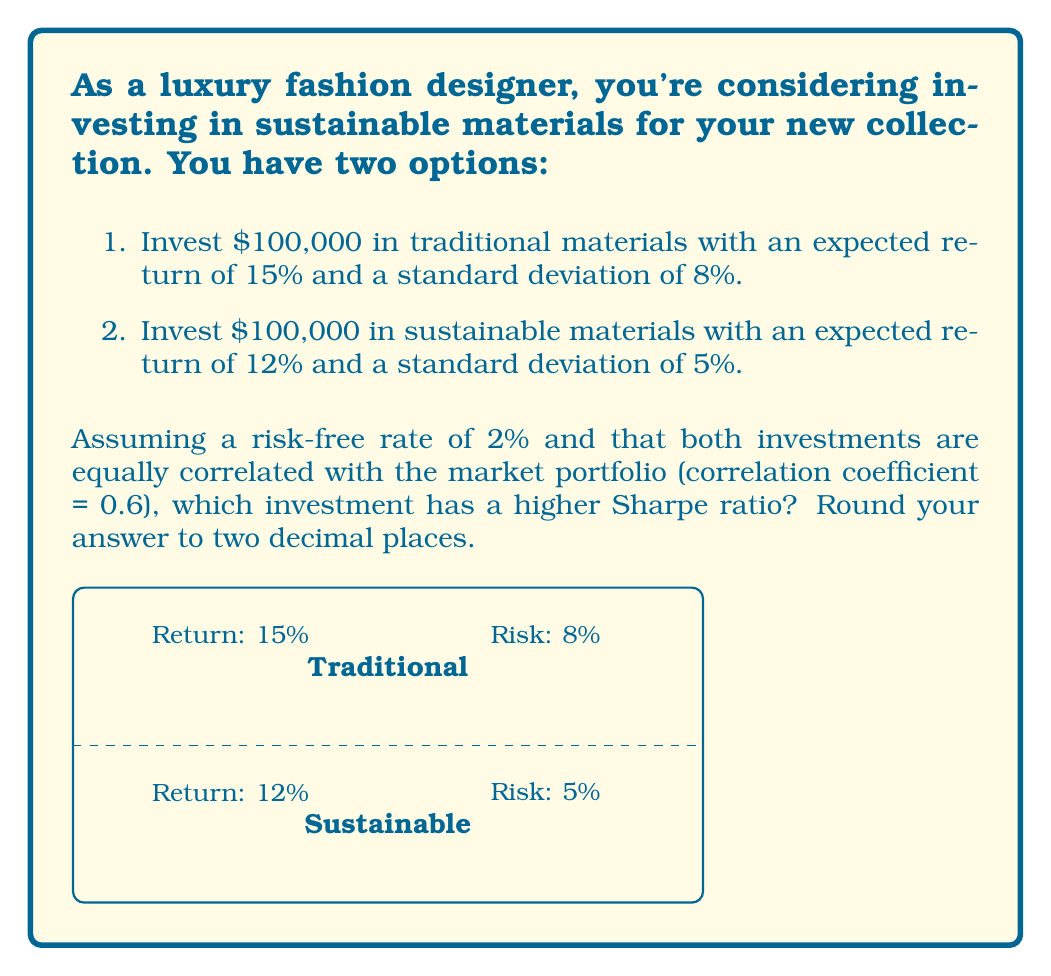What is the answer to this math problem? To determine which investment has a higher Sharpe ratio, we need to calculate the Sharpe ratio for both options. The Sharpe ratio is calculated using the following formula:

$$ \text{Sharpe Ratio} = \frac{R_p - R_f}{\sigma_p} $$

Where:
$R_p$ = Expected return of the portfolio
$R_f$ = Risk-free rate
$\sigma_p$ = Standard deviation of the portfolio (measure of risk)

Step 1: Calculate the Sharpe ratio for traditional materials
$$ \text{Sharpe Ratio}_{\text{traditional}} = \frac{0.15 - 0.02}{0.08} = 1.625 $$

Step 2: Calculate the Sharpe ratio for sustainable materials
$$ \text{Sharpe Ratio}_{\text{sustainable}} = \frac{0.12 - 0.02}{0.05} = 2 $$

Step 3: Compare the Sharpe ratios
The Sharpe ratio for sustainable materials (2.00) is higher than the Sharpe ratio for traditional materials (1.63), indicating that the sustainable materials offer a better risk-adjusted return.

Note: Both ratios are rounded to two decimal places as requested in the question.
Answer: Sustainable materials (2.00 vs 1.63) 